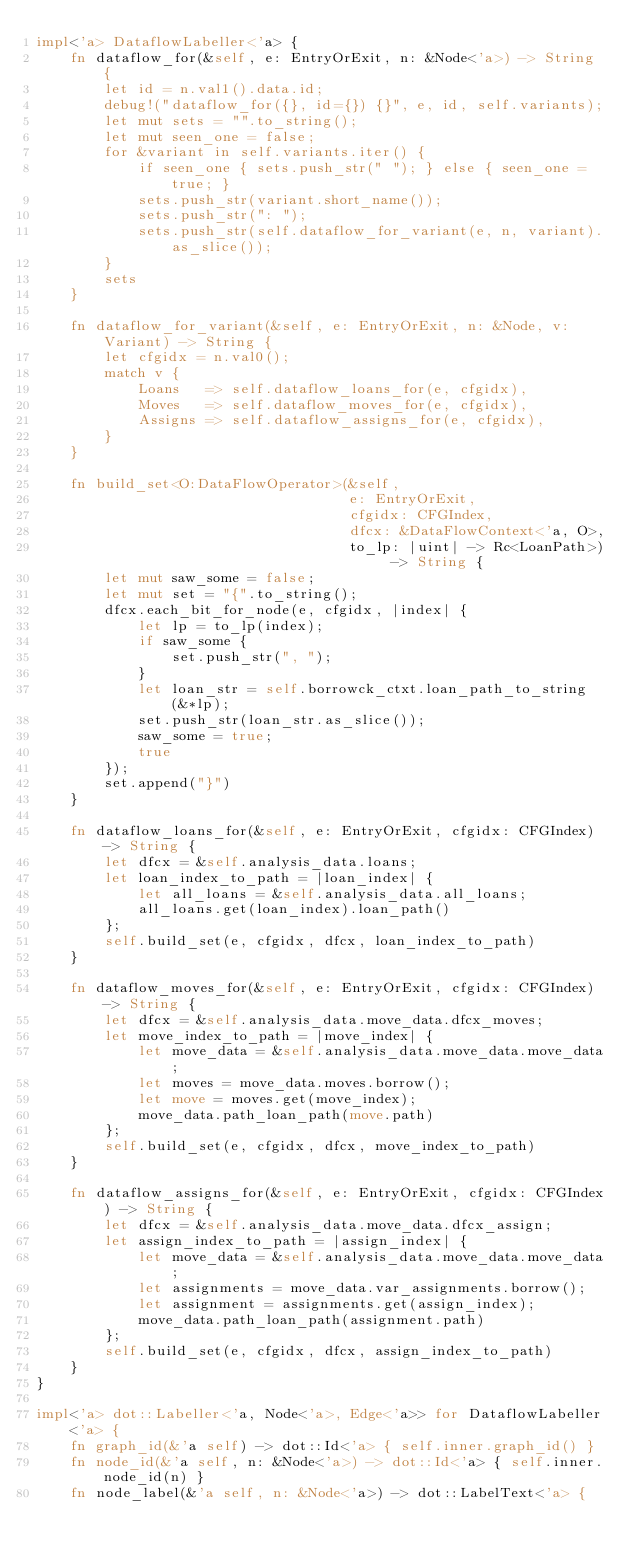<code> <loc_0><loc_0><loc_500><loc_500><_Rust_>impl<'a> DataflowLabeller<'a> {
    fn dataflow_for(&self, e: EntryOrExit, n: &Node<'a>) -> String {
        let id = n.val1().data.id;
        debug!("dataflow_for({}, id={}) {}", e, id, self.variants);
        let mut sets = "".to_string();
        let mut seen_one = false;
        for &variant in self.variants.iter() {
            if seen_one { sets.push_str(" "); } else { seen_one = true; }
            sets.push_str(variant.short_name());
            sets.push_str(": ");
            sets.push_str(self.dataflow_for_variant(e, n, variant).as_slice());
        }
        sets
    }

    fn dataflow_for_variant(&self, e: EntryOrExit, n: &Node, v: Variant) -> String {
        let cfgidx = n.val0();
        match v {
            Loans   => self.dataflow_loans_for(e, cfgidx),
            Moves   => self.dataflow_moves_for(e, cfgidx),
            Assigns => self.dataflow_assigns_for(e, cfgidx),
        }
    }

    fn build_set<O:DataFlowOperator>(&self,
                                     e: EntryOrExit,
                                     cfgidx: CFGIndex,
                                     dfcx: &DataFlowContext<'a, O>,
                                     to_lp: |uint| -> Rc<LoanPath>) -> String {
        let mut saw_some = false;
        let mut set = "{".to_string();
        dfcx.each_bit_for_node(e, cfgidx, |index| {
            let lp = to_lp(index);
            if saw_some {
                set.push_str(", ");
            }
            let loan_str = self.borrowck_ctxt.loan_path_to_string(&*lp);
            set.push_str(loan_str.as_slice());
            saw_some = true;
            true
        });
        set.append("}")
    }

    fn dataflow_loans_for(&self, e: EntryOrExit, cfgidx: CFGIndex) -> String {
        let dfcx = &self.analysis_data.loans;
        let loan_index_to_path = |loan_index| {
            let all_loans = &self.analysis_data.all_loans;
            all_loans.get(loan_index).loan_path()
        };
        self.build_set(e, cfgidx, dfcx, loan_index_to_path)
    }

    fn dataflow_moves_for(&self, e: EntryOrExit, cfgidx: CFGIndex) -> String {
        let dfcx = &self.analysis_data.move_data.dfcx_moves;
        let move_index_to_path = |move_index| {
            let move_data = &self.analysis_data.move_data.move_data;
            let moves = move_data.moves.borrow();
            let move = moves.get(move_index);
            move_data.path_loan_path(move.path)
        };
        self.build_set(e, cfgidx, dfcx, move_index_to_path)
    }

    fn dataflow_assigns_for(&self, e: EntryOrExit, cfgidx: CFGIndex) -> String {
        let dfcx = &self.analysis_data.move_data.dfcx_assign;
        let assign_index_to_path = |assign_index| {
            let move_data = &self.analysis_data.move_data.move_data;
            let assignments = move_data.var_assignments.borrow();
            let assignment = assignments.get(assign_index);
            move_data.path_loan_path(assignment.path)
        };
        self.build_set(e, cfgidx, dfcx, assign_index_to_path)
    }
}

impl<'a> dot::Labeller<'a, Node<'a>, Edge<'a>> for DataflowLabeller<'a> {
    fn graph_id(&'a self) -> dot::Id<'a> { self.inner.graph_id() }
    fn node_id(&'a self, n: &Node<'a>) -> dot::Id<'a> { self.inner.node_id(n) }
    fn node_label(&'a self, n: &Node<'a>) -> dot::LabelText<'a> {</code> 